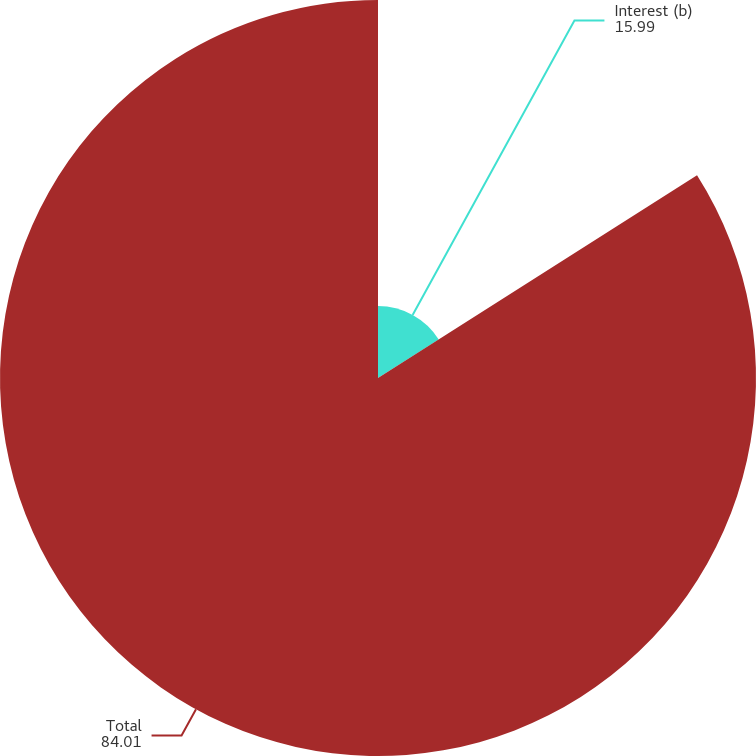Convert chart to OTSL. <chart><loc_0><loc_0><loc_500><loc_500><pie_chart><fcel>Interest (b)<fcel>Total<nl><fcel>15.99%<fcel>84.01%<nl></chart> 